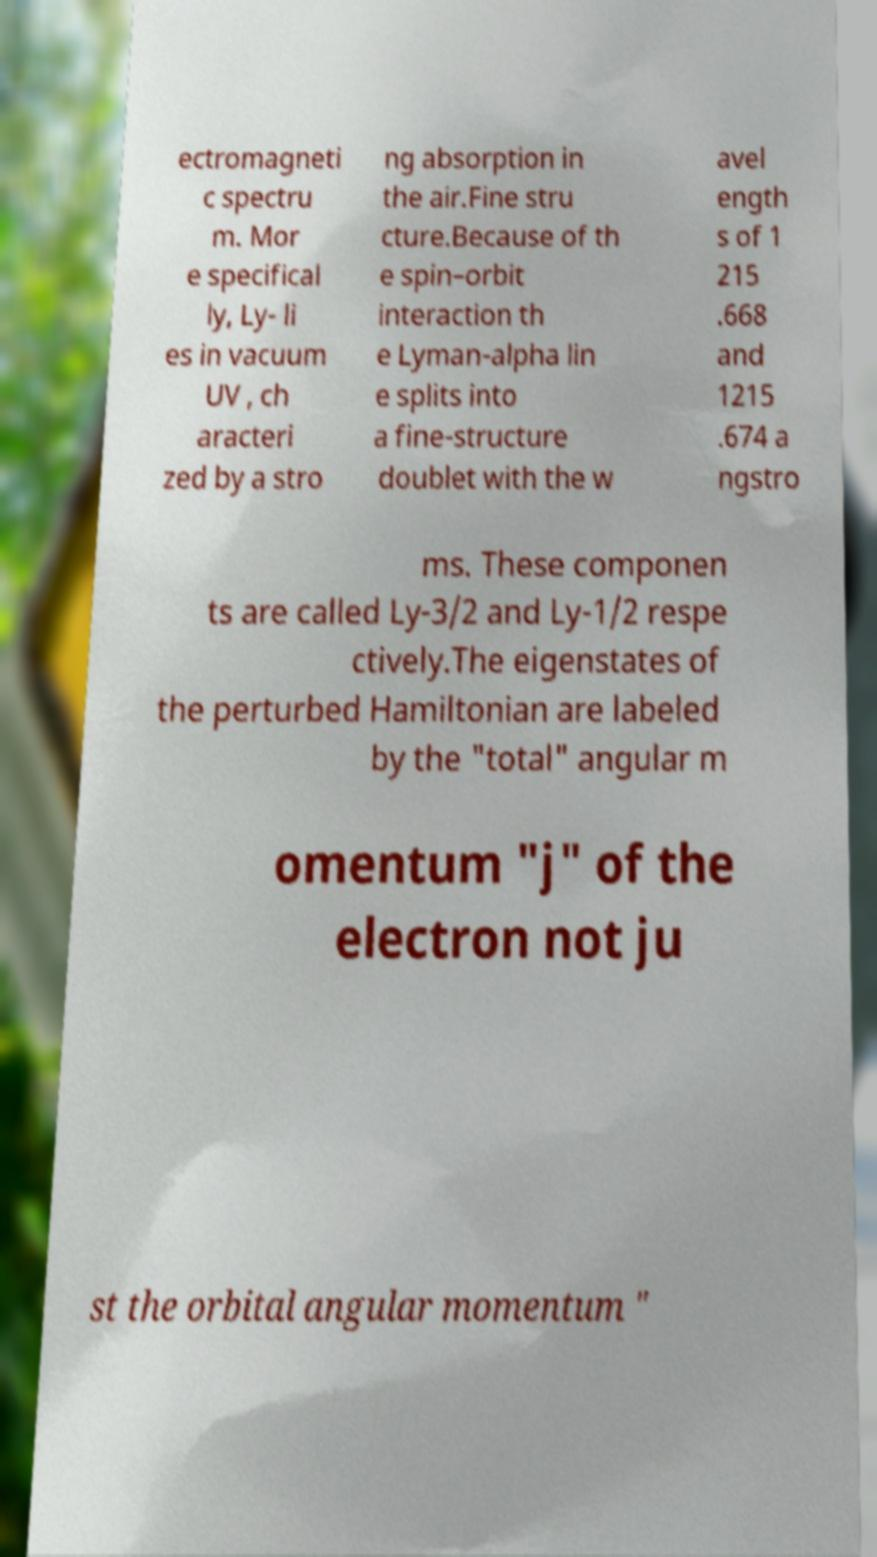I need the written content from this picture converted into text. Can you do that? ectromagneti c spectru m. Mor e specifical ly, Ly- li es in vacuum UV , ch aracteri zed by a stro ng absorption in the air.Fine stru cture.Because of th e spin–orbit interaction th e Lyman-alpha lin e splits into a fine-structure doublet with the w avel ength s of 1 215 .668 and 1215 .674 a ngstro ms. These componen ts are called Ly-3/2 and Ly-1/2 respe ctively.The eigenstates of the perturbed Hamiltonian are labeled by the "total" angular m omentum "j" of the electron not ju st the orbital angular momentum " 